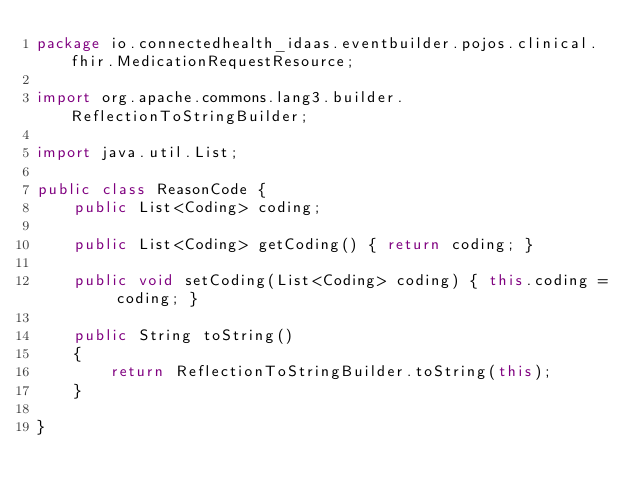<code> <loc_0><loc_0><loc_500><loc_500><_Java_>package io.connectedhealth_idaas.eventbuilder.pojos.clinical.fhir.MedicationRequestResource;

import org.apache.commons.lang3.builder.ReflectionToStringBuilder;

import java.util.List;

public class ReasonCode {
    public List<Coding> coding;

    public List<Coding> getCoding() { return coding; }

    public void setCoding(List<Coding> coding) { this.coding = coding; }

    public String toString()
    {
        return ReflectionToStringBuilder.toString(this);
    }

}
</code> 